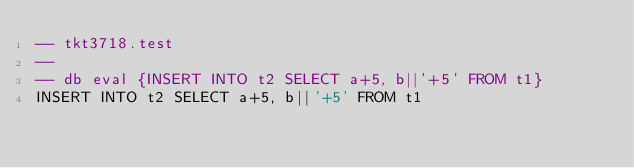Convert code to text. <code><loc_0><loc_0><loc_500><loc_500><_SQL_>-- tkt3718.test
-- 
-- db eval {INSERT INTO t2 SELECT a+5, b||'+5' FROM t1}
INSERT INTO t2 SELECT a+5, b||'+5' FROM t1</code> 